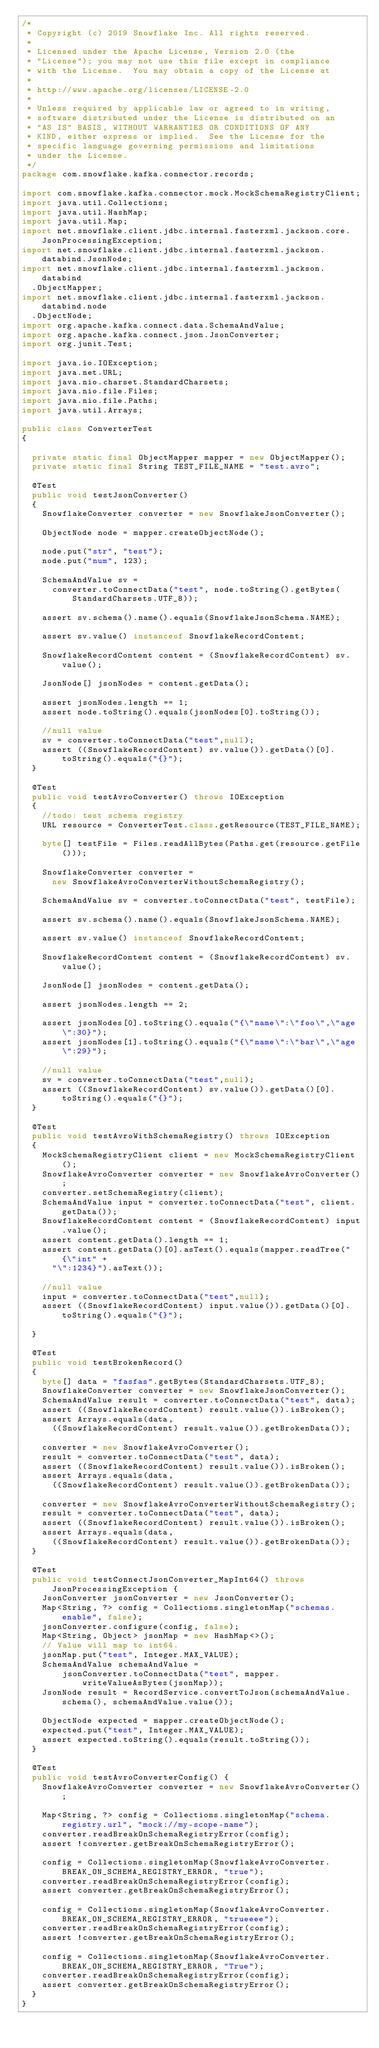<code> <loc_0><loc_0><loc_500><loc_500><_Java_>/*
 * Copyright (c) 2019 Snowflake Inc. All rights reserved.
 *
 * Licensed under the Apache License, Version 2.0 (the
 * "License"); you may not use this file except in compliance
 * with the License.  You may obtain a copy of the License at
 *
 * http://www.apache.org/licenses/LICENSE-2.0
 *
 * Unless required by applicable law or agreed to in writing,
 * software distributed under the License is distributed on an
 * "AS IS" BASIS, WITHOUT WARRANTIES OR CONDITIONS OF ANY
 * KIND, either express or implied.  See the License for the
 * specific language governing permissions and limitations
 * under the License.
 */
package com.snowflake.kafka.connector.records;

import com.snowflake.kafka.connector.mock.MockSchemaRegistryClient;
import java.util.Collections;
import java.util.HashMap;
import java.util.Map;
import net.snowflake.client.jdbc.internal.fasterxml.jackson.core.JsonProcessingException;
import net.snowflake.client.jdbc.internal.fasterxml.jackson.databind.JsonNode;
import net.snowflake.client.jdbc.internal.fasterxml.jackson.databind
  .ObjectMapper;
import net.snowflake.client.jdbc.internal.fasterxml.jackson.databind.node
  .ObjectNode;
import org.apache.kafka.connect.data.SchemaAndValue;
import org.apache.kafka.connect.json.JsonConverter;
import org.junit.Test;

import java.io.IOException;
import java.net.URL;
import java.nio.charset.StandardCharsets;
import java.nio.file.Files;
import java.nio.file.Paths;
import java.util.Arrays;

public class ConverterTest
{

  private static final ObjectMapper mapper = new ObjectMapper();
  private static final String TEST_FILE_NAME = "test.avro";

  @Test
  public void testJsonConverter()
  {
    SnowflakeConverter converter = new SnowflakeJsonConverter();

    ObjectNode node = mapper.createObjectNode();

    node.put("str", "test");
    node.put("num", 123);

    SchemaAndValue sv =
      converter.toConnectData("test", node.toString().getBytes(StandardCharsets.UTF_8));

    assert sv.schema().name().equals(SnowflakeJsonSchema.NAME);

    assert sv.value() instanceof SnowflakeRecordContent;

    SnowflakeRecordContent content = (SnowflakeRecordContent) sv.value();

    JsonNode[] jsonNodes = content.getData();

    assert jsonNodes.length == 1;
    assert node.toString().equals(jsonNodes[0].toString());

    //null value
    sv = converter.toConnectData("test",null);
    assert ((SnowflakeRecordContent) sv.value()).getData()[0].toString().equals("{}");
  }

  @Test
  public void testAvroConverter() throws IOException
  {
    //todo: test schema registry
    URL resource = ConverterTest.class.getResource(TEST_FILE_NAME);

    byte[] testFile = Files.readAllBytes(Paths.get(resource.getFile()));

    SnowflakeConverter converter =
      new SnowflakeAvroConverterWithoutSchemaRegistry();

    SchemaAndValue sv = converter.toConnectData("test", testFile);

    assert sv.schema().name().equals(SnowflakeJsonSchema.NAME);

    assert sv.value() instanceof SnowflakeRecordContent;

    SnowflakeRecordContent content = (SnowflakeRecordContent) sv.value();

    JsonNode[] jsonNodes = content.getData();

    assert jsonNodes.length == 2;

    assert jsonNodes[0].toString().equals("{\"name\":\"foo\",\"age\":30}");
    assert jsonNodes[1].toString().equals("{\"name\":\"bar\",\"age\":29}");

    //null value
    sv = converter.toConnectData("test",null);
    assert ((SnowflakeRecordContent) sv.value()).getData()[0].toString().equals("{}");
  }

  @Test
  public void testAvroWithSchemaRegistry() throws IOException
  {
    MockSchemaRegistryClient client = new MockSchemaRegistryClient();
    SnowflakeAvroConverter converter = new SnowflakeAvroConverter();
    converter.setSchemaRegistry(client);
    SchemaAndValue input = converter.toConnectData("test", client.getData());
    SnowflakeRecordContent content = (SnowflakeRecordContent) input.value();
    assert content.getData().length == 1;
    assert content.getData()[0].asText().equals(mapper.readTree("{\"int" +
      "\":1234}").asText());

    //null value
    input = converter.toConnectData("test",null);
    assert ((SnowflakeRecordContent) input.value()).getData()[0].toString().equals("{}");

  }

  @Test
  public void testBrokenRecord()
  {
    byte[] data = "fasfas".getBytes(StandardCharsets.UTF_8);
    SnowflakeConverter converter = new SnowflakeJsonConverter();
    SchemaAndValue result = converter.toConnectData("test", data);
    assert ((SnowflakeRecordContent) result.value()).isBroken();
    assert Arrays.equals(data,
      ((SnowflakeRecordContent) result.value()).getBrokenData());

    converter = new SnowflakeAvroConverter();
    result = converter.toConnectData("test", data);
    assert ((SnowflakeRecordContent) result.value()).isBroken();
    assert Arrays.equals(data,
      ((SnowflakeRecordContent) result.value()).getBrokenData());

    converter = new SnowflakeAvroConverterWithoutSchemaRegistry();
    result = converter.toConnectData("test", data);
    assert ((SnowflakeRecordContent) result.value()).isBroken();
    assert Arrays.equals(data,
      ((SnowflakeRecordContent) result.value()).getBrokenData());
  }

  @Test
  public void testConnectJsonConverter_MapInt64() throws JsonProcessingException {
    JsonConverter jsonConverter = new JsonConverter();
    Map<String, ?> config = Collections.singletonMap("schemas.enable", false);
    jsonConverter.configure(config, false);
    Map<String, Object> jsonMap = new HashMap<>();
    // Value will map to int64.
    jsonMap.put("test", Integer.MAX_VALUE);
    SchemaAndValue schemaAndValue =
        jsonConverter.toConnectData("test", mapper.writeValueAsBytes(jsonMap));
    JsonNode result = RecordService.convertToJson(schemaAndValue.schema(), schemaAndValue.value());

    ObjectNode expected = mapper.createObjectNode();
    expected.put("test", Integer.MAX_VALUE);
    assert expected.toString().equals(result.toString());
  }

  @Test
  public void testAvroConverterConfig() {
    SnowflakeAvroConverter converter = new SnowflakeAvroConverter();

    Map<String, ?> config = Collections.singletonMap("schema.registry.url", "mock://my-scope-name");
    converter.readBreakOnSchemaRegistryError(config);
    assert !converter.getBreakOnSchemaRegistryError();

    config = Collections.singletonMap(SnowflakeAvroConverter.BREAK_ON_SCHEMA_REGISTRY_ERROR, "true");
    converter.readBreakOnSchemaRegistryError(config);
    assert converter.getBreakOnSchemaRegistryError();

    config = Collections.singletonMap(SnowflakeAvroConverter.BREAK_ON_SCHEMA_REGISTRY_ERROR, "trueeee");
    converter.readBreakOnSchemaRegistryError(config);
    assert !converter.getBreakOnSchemaRegistryError();

    config = Collections.singletonMap(SnowflakeAvroConverter.BREAK_ON_SCHEMA_REGISTRY_ERROR, "True");
    converter.readBreakOnSchemaRegistryError(config);
    assert converter.getBreakOnSchemaRegistryError();
  }
}
</code> 